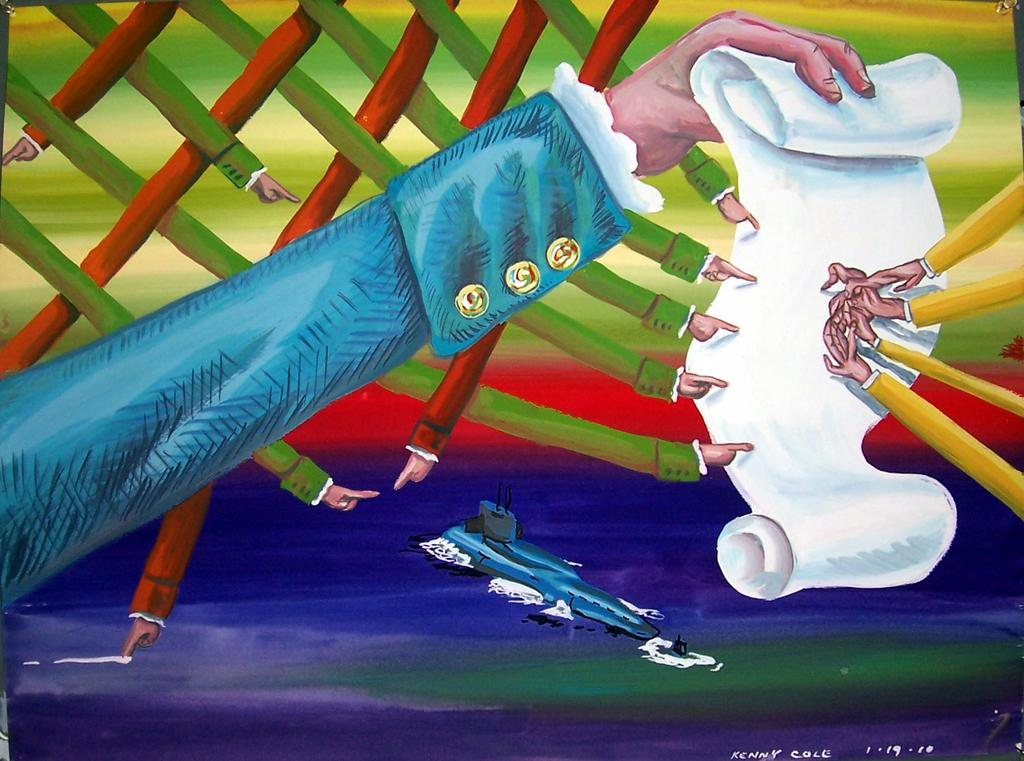What is the main subject of the image? There is a painting in the image. What is being depicted in the painting? The painting depicts people's hands. Are there any additional elements in the painting besides the hands? Yes, there are objects present in the painting. Is there any text included in the painting? Yes, there is text on the painting. Can you tell me the name of the parent featured in the painting? There is no parent present in the painting; it depicts people's hands. What type of book is being read by the person in the painting? There is no book or person reading a book in the painting; it depicts people's hands and objects. 